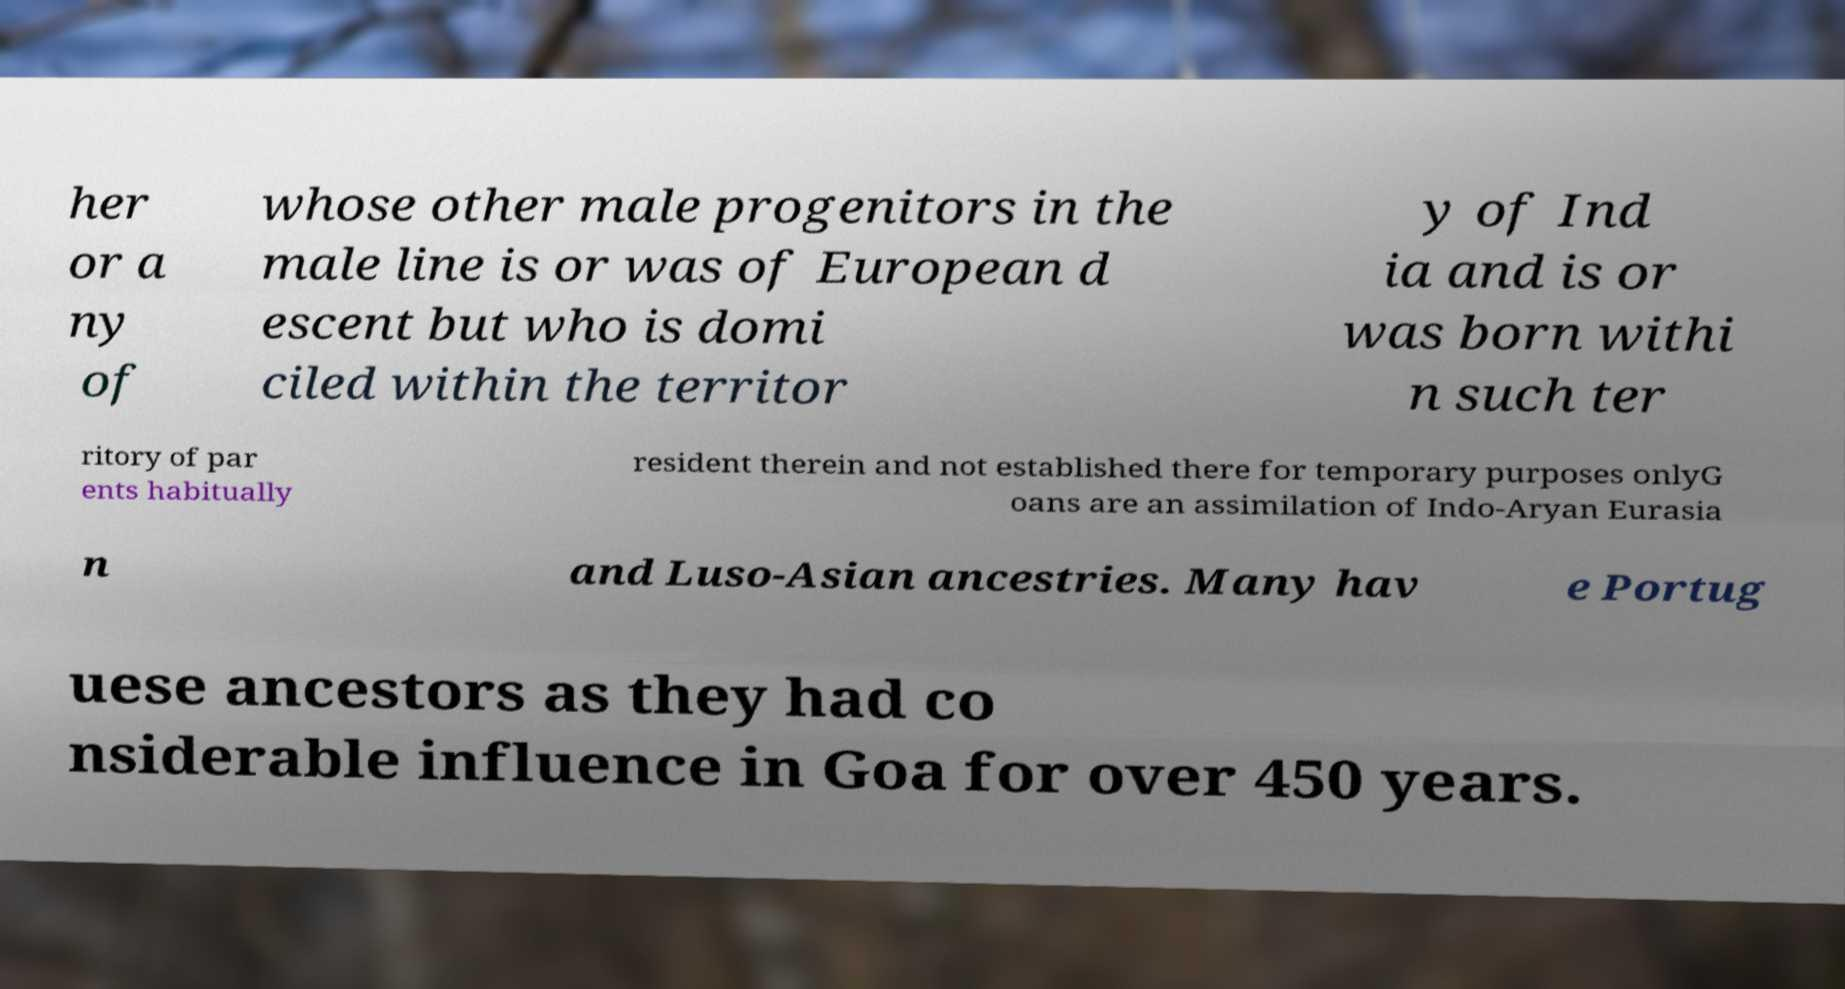There's text embedded in this image that I need extracted. Can you transcribe it verbatim? her or a ny of whose other male progenitors in the male line is or was of European d escent but who is domi ciled within the territor y of Ind ia and is or was born withi n such ter ritory of par ents habitually resident therein and not established there for temporary purposes onlyG oans are an assimilation of Indo-Aryan Eurasia n and Luso-Asian ancestries. Many hav e Portug uese ancestors as they had co nsiderable influence in Goa for over 450 years. 